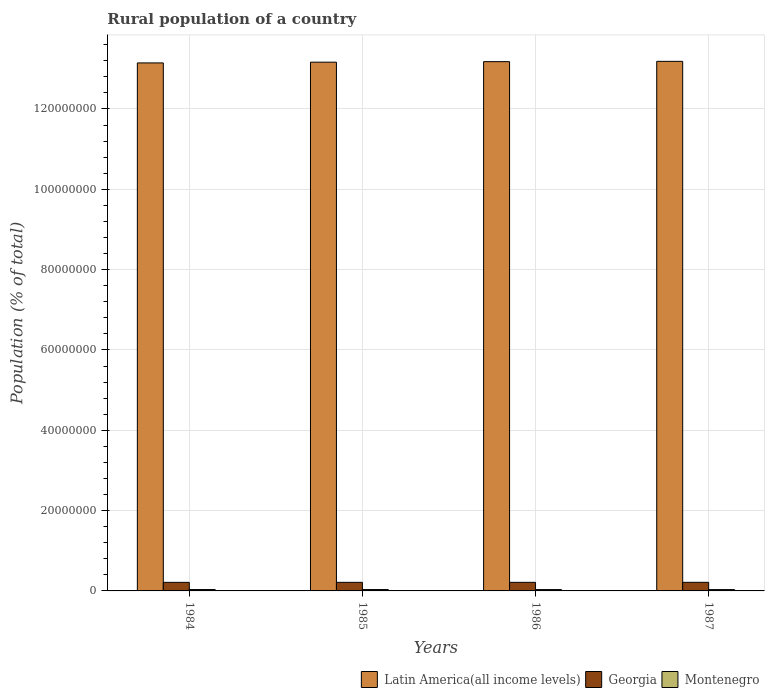How many different coloured bars are there?
Provide a short and direct response. 3. Are the number of bars on each tick of the X-axis equal?
Your response must be concise. Yes. How many bars are there on the 1st tick from the left?
Provide a succinct answer. 3. What is the label of the 3rd group of bars from the left?
Provide a succinct answer. 1986. In how many cases, is the number of bars for a given year not equal to the number of legend labels?
Offer a terse response. 0. What is the rural population in Georgia in 1984?
Keep it short and to the point. 2.13e+06. Across all years, what is the maximum rural population in Montenegro?
Provide a short and direct response. 3.44e+05. Across all years, what is the minimum rural population in Latin America(all income levels)?
Make the answer very short. 1.31e+08. What is the total rural population in Latin America(all income levels) in the graph?
Keep it short and to the point. 5.27e+08. What is the difference between the rural population in Montenegro in 1984 and that in 1987?
Your answer should be compact. 1.32e+04. What is the difference between the rural population in Latin America(all income levels) in 1986 and the rural population in Georgia in 1984?
Your answer should be very brief. 1.30e+08. What is the average rural population in Georgia per year?
Provide a short and direct response. 2.14e+06. In the year 1984, what is the difference between the rural population in Montenegro and rural population in Georgia?
Your response must be concise. -1.79e+06. What is the ratio of the rural population in Montenegro in 1984 to that in 1987?
Ensure brevity in your answer.  1.04. Is the rural population in Latin America(all income levels) in 1984 less than that in 1987?
Offer a terse response. Yes. What is the difference between the highest and the second highest rural population in Georgia?
Your answer should be compact. 1700. What is the difference between the highest and the lowest rural population in Georgia?
Offer a very short reply. 7828. In how many years, is the rural population in Georgia greater than the average rural population in Georgia taken over all years?
Give a very brief answer. 2. What does the 1st bar from the left in 1986 represents?
Keep it short and to the point. Latin America(all income levels). What does the 3rd bar from the right in 1987 represents?
Provide a short and direct response. Latin America(all income levels). Is it the case that in every year, the sum of the rural population in Latin America(all income levels) and rural population in Montenegro is greater than the rural population in Georgia?
Your answer should be very brief. Yes. How many bars are there?
Ensure brevity in your answer.  12. How many years are there in the graph?
Offer a very short reply. 4. What is the difference between two consecutive major ticks on the Y-axis?
Give a very brief answer. 2.00e+07. What is the title of the graph?
Your answer should be very brief. Rural population of a country. What is the label or title of the X-axis?
Offer a terse response. Years. What is the label or title of the Y-axis?
Provide a succinct answer. Population (% of total). What is the Population (% of total) of Latin America(all income levels) in 1984?
Ensure brevity in your answer.  1.31e+08. What is the Population (% of total) of Georgia in 1984?
Give a very brief answer. 2.13e+06. What is the Population (% of total) in Montenegro in 1984?
Offer a very short reply. 3.44e+05. What is the Population (% of total) of Latin America(all income levels) in 1985?
Give a very brief answer. 1.32e+08. What is the Population (% of total) of Georgia in 1985?
Offer a very short reply. 2.14e+06. What is the Population (% of total) in Montenegro in 1985?
Your answer should be very brief. 3.39e+05. What is the Population (% of total) in Latin America(all income levels) in 1986?
Provide a succinct answer. 1.32e+08. What is the Population (% of total) in Georgia in 1986?
Give a very brief answer. 2.14e+06. What is the Population (% of total) of Montenegro in 1986?
Provide a short and direct response. 3.35e+05. What is the Population (% of total) of Latin America(all income levels) in 1987?
Provide a succinct answer. 1.32e+08. What is the Population (% of total) of Georgia in 1987?
Your response must be concise. 2.14e+06. What is the Population (% of total) in Montenegro in 1987?
Give a very brief answer. 3.31e+05. Across all years, what is the maximum Population (% of total) of Latin America(all income levels)?
Provide a short and direct response. 1.32e+08. Across all years, what is the maximum Population (% of total) in Georgia?
Offer a terse response. 2.14e+06. Across all years, what is the maximum Population (% of total) of Montenegro?
Make the answer very short. 3.44e+05. Across all years, what is the minimum Population (% of total) of Latin America(all income levels)?
Keep it short and to the point. 1.31e+08. Across all years, what is the minimum Population (% of total) of Georgia?
Ensure brevity in your answer.  2.13e+06. Across all years, what is the minimum Population (% of total) in Montenegro?
Your answer should be compact. 3.31e+05. What is the total Population (% of total) in Latin America(all income levels) in the graph?
Make the answer very short. 5.27e+08. What is the total Population (% of total) of Georgia in the graph?
Your answer should be compact. 8.55e+06. What is the total Population (% of total) in Montenegro in the graph?
Your answer should be compact. 1.35e+06. What is the difference between the Population (% of total) of Latin America(all income levels) in 1984 and that in 1985?
Your answer should be very brief. -1.81e+05. What is the difference between the Population (% of total) in Georgia in 1984 and that in 1985?
Ensure brevity in your answer.  -2974. What is the difference between the Population (% of total) of Montenegro in 1984 and that in 1985?
Your answer should be very brief. 4615. What is the difference between the Population (% of total) of Latin America(all income levels) in 1984 and that in 1986?
Your answer should be very brief. -3.13e+05. What is the difference between the Population (% of total) in Georgia in 1984 and that in 1986?
Ensure brevity in your answer.  -6128. What is the difference between the Population (% of total) in Montenegro in 1984 and that in 1986?
Ensure brevity in your answer.  8977. What is the difference between the Population (% of total) in Latin America(all income levels) in 1984 and that in 1987?
Keep it short and to the point. -3.88e+05. What is the difference between the Population (% of total) in Georgia in 1984 and that in 1987?
Keep it short and to the point. -7828. What is the difference between the Population (% of total) in Montenegro in 1984 and that in 1987?
Offer a terse response. 1.32e+04. What is the difference between the Population (% of total) in Latin America(all income levels) in 1985 and that in 1986?
Your response must be concise. -1.32e+05. What is the difference between the Population (% of total) of Georgia in 1985 and that in 1986?
Make the answer very short. -3154. What is the difference between the Population (% of total) in Montenegro in 1985 and that in 1986?
Offer a terse response. 4362. What is the difference between the Population (% of total) in Latin America(all income levels) in 1985 and that in 1987?
Your answer should be very brief. -2.06e+05. What is the difference between the Population (% of total) in Georgia in 1985 and that in 1987?
Give a very brief answer. -4854. What is the difference between the Population (% of total) of Montenegro in 1985 and that in 1987?
Provide a succinct answer. 8585. What is the difference between the Population (% of total) in Latin America(all income levels) in 1986 and that in 1987?
Provide a short and direct response. -7.44e+04. What is the difference between the Population (% of total) in Georgia in 1986 and that in 1987?
Your response must be concise. -1700. What is the difference between the Population (% of total) in Montenegro in 1986 and that in 1987?
Make the answer very short. 4223. What is the difference between the Population (% of total) in Latin America(all income levels) in 1984 and the Population (% of total) in Georgia in 1985?
Your response must be concise. 1.29e+08. What is the difference between the Population (% of total) in Latin America(all income levels) in 1984 and the Population (% of total) in Montenegro in 1985?
Make the answer very short. 1.31e+08. What is the difference between the Population (% of total) in Georgia in 1984 and the Population (% of total) in Montenegro in 1985?
Your answer should be compact. 1.79e+06. What is the difference between the Population (% of total) in Latin America(all income levels) in 1984 and the Population (% of total) in Georgia in 1986?
Provide a succinct answer. 1.29e+08. What is the difference between the Population (% of total) of Latin America(all income levels) in 1984 and the Population (% of total) of Montenegro in 1986?
Your answer should be very brief. 1.31e+08. What is the difference between the Population (% of total) of Georgia in 1984 and the Population (% of total) of Montenegro in 1986?
Provide a short and direct response. 1.80e+06. What is the difference between the Population (% of total) of Latin America(all income levels) in 1984 and the Population (% of total) of Georgia in 1987?
Your response must be concise. 1.29e+08. What is the difference between the Population (% of total) in Latin America(all income levels) in 1984 and the Population (% of total) in Montenegro in 1987?
Your response must be concise. 1.31e+08. What is the difference between the Population (% of total) of Georgia in 1984 and the Population (% of total) of Montenegro in 1987?
Make the answer very short. 1.80e+06. What is the difference between the Population (% of total) of Latin America(all income levels) in 1985 and the Population (% of total) of Georgia in 1986?
Ensure brevity in your answer.  1.30e+08. What is the difference between the Population (% of total) of Latin America(all income levels) in 1985 and the Population (% of total) of Montenegro in 1986?
Make the answer very short. 1.31e+08. What is the difference between the Population (% of total) in Georgia in 1985 and the Population (% of total) in Montenegro in 1986?
Offer a terse response. 1.80e+06. What is the difference between the Population (% of total) in Latin America(all income levels) in 1985 and the Population (% of total) in Georgia in 1987?
Offer a terse response. 1.30e+08. What is the difference between the Population (% of total) of Latin America(all income levels) in 1985 and the Population (% of total) of Montenegro in 1987?
Make the answer very short. 1.31e+08. What is the difference between the Population (% of total) of Georgia in 1985 and the Population (% of total) of Montenegro in 1987?
Your answer should be very brief. 1.81e+06. What is the difference between the Population (% of total) in Latin America(all income levels) in 1986 and the Population (% of total) in Georgia in 1987?
Your answer should be compact. 1.30e+08. What is the difference between the Population (% of total) of Latin America(all income levels) in 1986 and the Population (% of total) of Montenegro in 1987?
Give a very brief answer. 1.31e+08. What is the difference between the Population (% of total) in Georgia in 1986 and the Population (% of total) in Montenegro in 1987?
Offer a terse response. 1.81e+06. What is the average Population (% of total) of Latin America(all income levels) per year?
Make the answer very short. 1.32e+08. What is the average Population (% of total) of Georgia per year?
Provide a short and direct response. 2.14e+06. What is the average Population (% of total) in Montenegro per year?
Your answer should be compact. 3.37e+05. In the year 1984, what is the difference between the Population (% of total) of Latin America(all income levels) and Population (% of total) of Georgia?
Your response must be concise. 1.29e+08. In the year 1984, what is the difference between the Population (% of total) of Latin America(all income levels) and Population (% of total) of Montenegro?
Offer a terse response. 1.31e+08. In the year 1984, what is the difference between the Population (% of total) of Georgia and Population (% of total) of Montenegro?
Keep it short and to the point. 1.79e+06. In the year 1985, what is the difference between the Population (% of total) in Latin America(all income levels) and Population (% of total) in Georgia?
Provide a short and direct response. 1.30e+08. In the year 1985, what is the difference between the Population (% of total) in Latin America(all income levels) and Population (% of total) in Montenegro?
Your answer should be very brief. 1.31e+08. In the year 1985, what is the difference between the Population (% of total) of Georgia and Population (% of total) of Montenegro?
Offer a terse response. 1.80e+06. In the year 1986, what is the difference between the Population (% of total) of Latin America(all income levels) and Population (% of total) of Georgia?
Ensure brevity in your answer.  1.30e+08. In the year 1986, what is the difference between the Population (% of total) in Latin America(all income levels) and Population (% of total) in Montenegro?
Give a very brief answer. 1.31e+08. In the year 1986, what is the difference between the Population (% of total) in Georgia and Population (% of total) in Montenegro?
Your answer should be compact. 1.80e+06. In the year 1987, what is the difference between the Population (% of total) in Latin America(all income levels) and Population (% of total) in Georgia?
Give a very brief answer. 1.30e+08. In the year 1987, what is the difference between the Population (% of total) of Latin America(all income levels) and Population (% of total) of Montenegro?
Your answer should be very brief. 1.32e+08. In the year 1987, what is the difference between the Population (% of total) of Georgia and Population (% of total) of Montenegro?
Your answer should be very brief. 1.81e+06. What is the ratio of the Population (% of total) of Georgia in 1984 to that in 1985?
Provide a succinct answer. 1. What is the ratio of the Population (% of total) in Montenegro in 1984 to that in 1985?
Ensure brevity in your answer.  1.01. What is the ratio of the Population (% of total) of Montenegro in 1984 to that in 1986?
Offer a terse response. 1.03. What is the ratio of the Population (% of total) in Latin America(all income levels) in 1984 to that in 1987?
Provide a succinct answer. 1. What is the ratio of the Population (% of total) of Georgia in 1984 to that in 1987?
Offer a terse response. 1. What is the ratio of the Population (% of total) in Montenegro in 1984 to that in 1987?
Give a very brief answer. 1.04. What is the ratio of the Population (% of total) of Latin America(all income levels) in 1985 to that in 1986?
Offer a very short reply. 1. What is the ratio of the Population (% of total) of Georgia in 1985 to that in 1986?
Provide a succinct answer. 1. What is the ratio of the Population (% of total) of Montenegro in 1985 to that in 1986?
Make the answer very short. 1.01. What is the ratio of the Population (% of total) of Latin America(all income levels) in 1985 to that in 1987?
Your answer should be compact. 1. What is the ratio of the Population (% of total) in Georgia in 1985 to that in 1987?
Give a very brief answer. 1. What is the ratio of the Population (% of total) of Latin America(all income levels) in 1986 to that in 1987?
Offer a very short reply. 1. What is the ratio of the Population (% of total) of Montenegro in 1986 to that in 1987?
Provide a succinct answer. 1.01. What is the difference between the highest and the second highest Population (% of total) of Latin America(all income levels)?
Make the answer very short. 7.44e+04. What is the difference between the highest and the second highest Population (% of total) in Georgia?
Offer a terse response. 1700. What is the difference between the highest and the second highest Population (% of total) of Montenegro?
Your answer should be very brief. 4615. What is the difference between the highest and the lowest Population (% of total) in Latin America(all income levels)?
Your response must be concise. 3.88e+05. What is the difference between the highest and the lowest Population (% of total) of Georgia?
Your answer should be very brief. 7828. What is the difference between the highest and the lowest Population (% of total) in Montenegro?
Provide a succinct answer. 1.32e+04. 